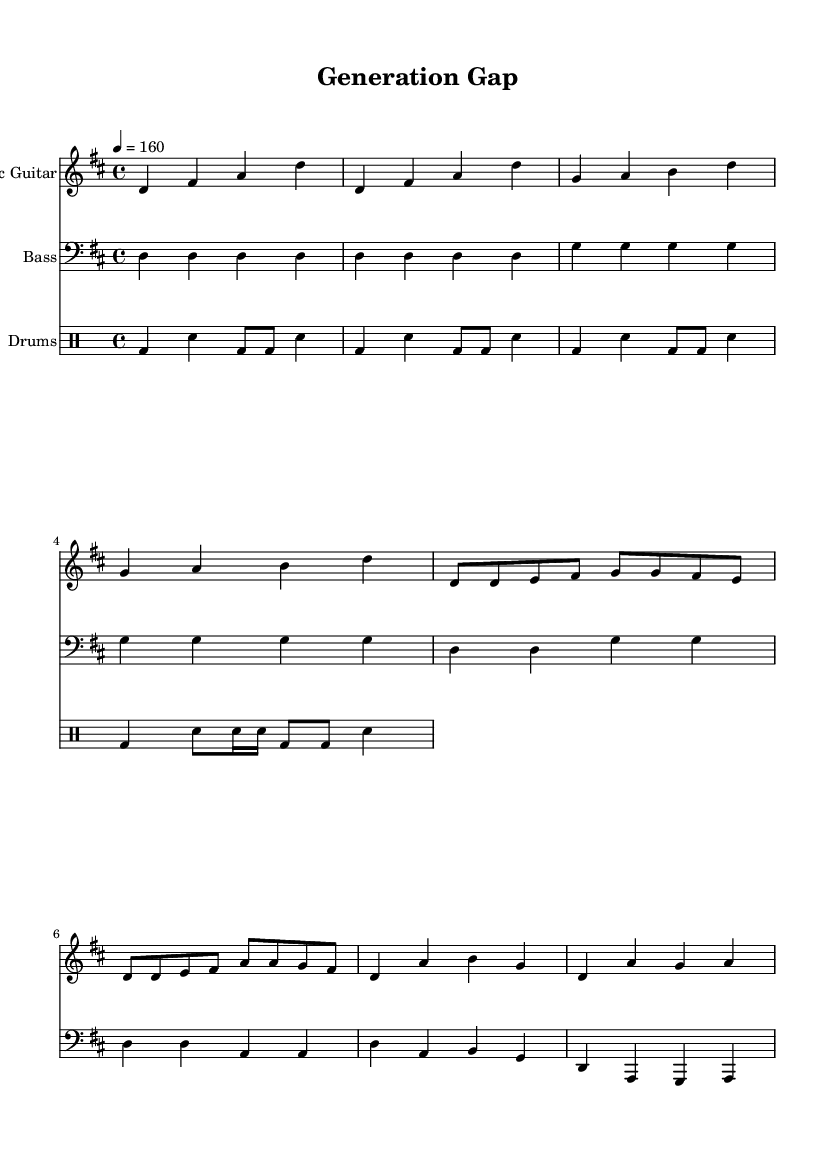What is the key signature of this music? The key signature is D major, which has two sharps (F# and C#). This can be determined by examining the key signature at the beginning of the staff, where the notes indicate F# and C#.
Answer: D major What is the time signature of this music? The time signature is 4/4, which is indicated at the beginning of the score. It signifies that there are four beats per measure and the quarter note receives one beat.
Answer: 4/4 What is the tempo marking for this piece? The tempo is marked as "4 = 160", meaning the quarter note is played at a speed of 160 beats per minute. This is seen in the tempo indication at the top of the score.
Answer: 160 What is the main rhythmic pattern used in the drum part? The main rhythmic pattern is a basic punk beat, characterized by a bass drum on the first and third beats, with snare on the second and fourth beats. This is evident in the way the drum notes are structured across the measures.
Answer: Basic punk beat How many measures are in the intro section? The intro section contains four measures, which can be counted by examining the measure bars and seeing that the notes are grouped into four distinct measures before moving into the verse.
Answer: 4 What is the highest note played in the electric guitar part? The highest note in the electric guitar part is B, which can be identified by scanning through the notes in the guitar staff and noting the pitches that appear. B is found in the chorus section.
Answer: B What unique punk sound element is emphasized in this music? The music emphasizes power chords, which are common in punk music, characterized by playing the root and the fifth of the chord. This can be inferred from the presence of simple chord transitions and the energetic style reflected in the notes.
Answer: Power chords 